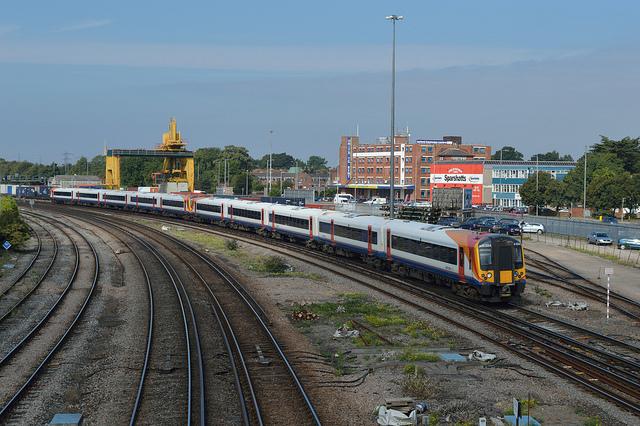Does this photo show train tracks?
Answer briefly. Yes. Does this train work?
Short answer required. Yes. Is this train headed towards or from the orange building?
Quick response, please. From. 